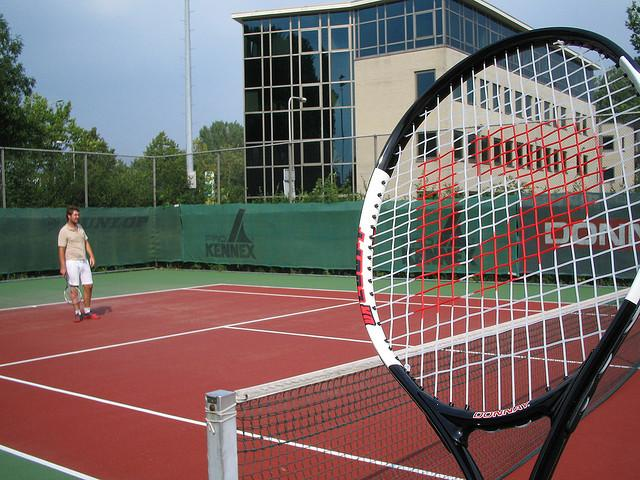Who plays this sport? tennis players 